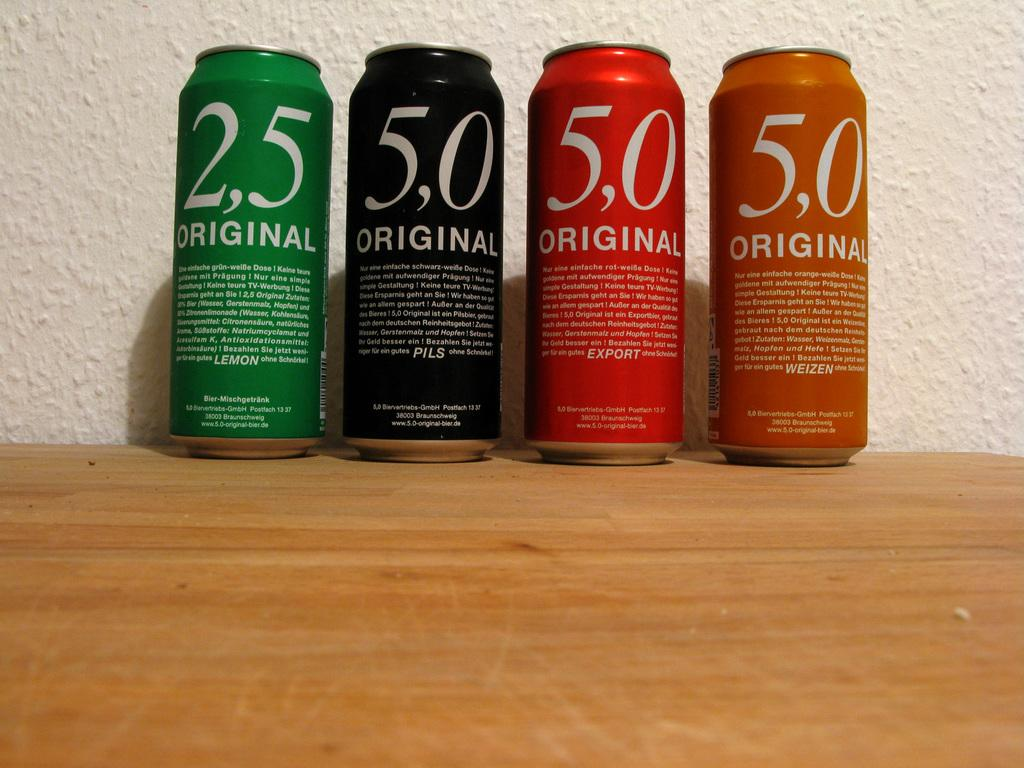<image>
Summarize the visual content of the image. Green, Black, Red, and Orange cans sit in a row call labeled Original with their respective flavors listed in the descriptions on each can 